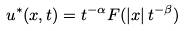<formula> <loc_0><loc_0><loc_500><loc_500>u ^ { * } ( x , t ) = t ^ { - \alpha } F ( | x | \, t ^ { - \beta } )</formula> 